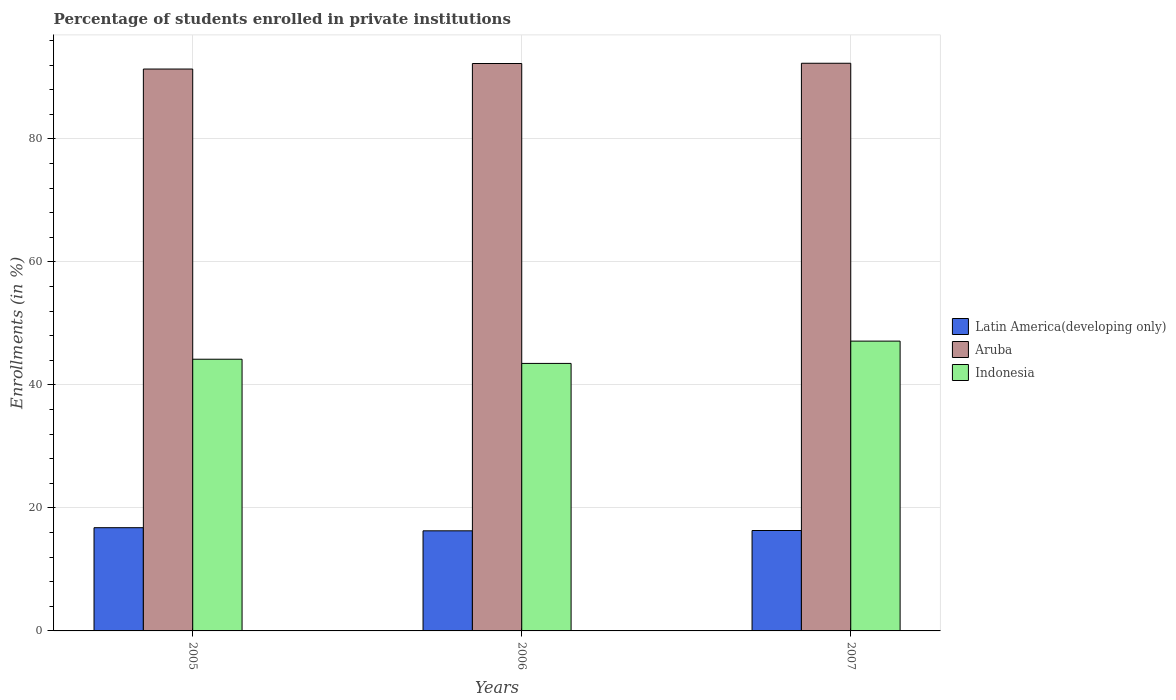How many different coloured bars are there?
Give a very brief answer. 3. What is the label of the 2nd group of bars from the left?
Ensure brevity in your answer.  2006. What is the percentage of trained teachers in Aruba in 2005?
Offer a very short reply. 91.34. Across all years, what is the maximum percentage of trained teachers in Indonesia?
Provide a short and direct response. 47.11. Across all years, what is the minimum percentage of trained teachers in Latin America(developing only)?
Provide a short and direct response. 16.27. In which year was the percentage of trained teachers in Indonesia minimum?
Your answer should be very brief. 2006. What is the total percentage of trained teachers in Indonesia in the graph?
Provide a succinct answer. 134.77. What is the difference between the percentage of trained teachers in Aruba in 2006 and that in 2007?
Ensure brevity in your answer.  -0.04. What is the difference between the percentage of trained teachers in Latin America(developing only) in 2007 and the percentage of trained teachers in Aruba in 2006?
Your answer should be very brief. -75.92. What is the average percentage of trained teachers in Latin America(developing only) per year?
Your response must be concise. 16.46. In the year 2005, what is the difference between the percentage of trained teachers in Indonesia and percentage of trained teachers in Aruba?
Offer a very short reply. -47.17. In how many years, is the percentage of trained teachers in Latin America(developing only) greater than 20 %?
Ensure brevity in your answer.  0. What is the ratio of the percentage of trained teachers in Indonesia in 2006 to that in 2007?
Ensure brevity in your answer.  0.92. What is the difference between the highest and the second highest percentage of trained teachers in Aruba?
Offer a very short reply. 0.04. What is the difference between the highest and the lowest percentage of trained teachers in Indonesia?
Make the answer very short. 3.62. What does the 2nd bar from the left in 2006 represents?
Offer a terse response. Aruba. What does the 3rd bar from the right in 2005 represents?
Make the answer very short. Latin America(developing only). Is it the case that in every year, the sum of the percentage of trained teachers in Indonesia and percentage of trained teachers in Aruba is greater than the percentage of trained teachers in Latin America(developing only)?
Make the answer very short. Yes. How many bars are there?
Offer a very short reply. 9. Are all the bars in the graph horizontal?
Make the answer very short. No. How many years are there in the graph?
Offer a terse response. 3. What is the difference between two consecutive major ticks on the Y-axis?
Make the answer very short. 20. Are the values on the major ticks of Y-axis written in scientific E-notation?
Offer a terse response. No. Does the graph contain grids?
Keep it short and to the point. Yes. Where does the legend appear in the graph?
Make the answer very short. Center right. How many legend labels are there?
Keep it short and to the point. 3. How are the legend labels stacked?
Your answer should be compact. Vertical. What is the title of the graph?
Give a very brief answer. Percentage of students enrolled in private institutions. Does "Low income" appear as one of the legend labels in the graph?
Provide a succinct answer. No. What is the label or title of the Y-axis?
Offer a very short reply. Enrollments (in %). What is the Enrollments (in %) in Latin America(developing only) in 2005?
Your response must be concise. 16.78. What is the Enrollments (in %) in Aruba in 2005?
Offer a terse response. 91.34. What is the Enrollments (in %) of Indonesia in 2005?
Ensure brevity in your answer.  44.17. What is the Enrollments (in %) in Latin America(developing only) in 2006?
Your response must be concise. 16.27. What is the Enrollments (in %) in Aruba in 2006?
Make the answer very short. 92.24. What is the Enrollments (in %) in Indonesia in 2006?
Your answer should be very brief. 43.49. What is the Enrollments (in %) of Latin America(developing only) in 2007?
Provide a short and direct response. 16.32. What is the Enrollments (in %) of Aruba in 2007?
Give a very brief answer. 92.28. What is the Enrollments (in %) of Indonesia in 2007?
Provide a succinct answer. 47.11. Across all years, what is the maximum Enrollments (in %) in Latin America(developing only)?
Ensure brevity in your answer.  16.78. Across all years, what is the maximum Enrollments (in %) in Aruba?
Make the answer very short. 92.28. Across all years, what is the maximum Enrollments (in %) in Indonesia?
Give a very brief answer. 47.11. Across all years, what is the minimum Enrollments (in %) in Latin America(developing only)?
Make the answer very short. 16.27. Across all years, what is the minimum Enrollments (in %) in Aruba?
Provide a short and direct response. 91.34. Across all years, what is the minimum Enrollments (in %) of Indonesia?
Give a very brief answer. 43.49. What is the total Enrollments (in %) in Latin America(developing only) in the graph?
Offer a terse response. 49.38. What is the total Enrollments (in %) in Aruba in the graph?
Your response must be concise. 275.87. What is the total Enrollments (in %) in Indonesia in the graph?
Offer a very short reply. 134.77. What is the difference between the Enrollments (in %) of Latin America(developing only) in 2005 and that in 2006?
Your response must be concise. 0.51. What is the difference between the Enrollments (in %) of Aruba in 2005 and that in 2006?
Offer a terse response. -0.9. What is the difference between the Enrollments (in %) of Indonesia in 2005 and that in 2006?
Provide a short and direct response. 0.68. What is the difference between the Enrollments (in %) of Latin America(developing only) in 2005 and that in 2007?
Keep it short and to the point. 0.46. What is the difference between the Enrollments (in %) of Aruba in 2005 and that in 2007?
Provide a succinct answer. -0.94. What is the difference between the Enrollments (in %) of Indonesia in 2005 and that in 2007?
Ensure brevity in your answer.  -2.94. What is the difference between the Enrollments (in %) of Latin America(developing only) in 2006 and that in 2007?
Your answer should be very brief. -0.05. What is the difference between the Enrollments (in %) in Aruba in 2006 and that in 2007?
Give a very brief answer. -0.04. What is the difference between the Enrollments (in %) in Indonesia in 2006 and that in 2007?
Your answer should be compact. -3.62. What is the difference between the Enrollments (in %) of Latin America(developing only) in 2005 and the Enrollments (in %) of Aruba in 2006?
Provide a short and direct response. -75.46. What is the difference between the Enrollments (in %) of Latin America(developing only) in 2005 and the Enrollments (in %) of Indonesia in 2006?
Offer a very short reply. -26.71. What is the difference between the Enrollments (in %) in Aruba in 2005 and the Enrollments (in %) in Indonesia in 2006?
Your response must be concise. 47.85. What is the difference between the Enrollments (in %) in Latin America(developing only) in 2005 and the Enrollments (in %) in Aruba in 2007?
Your answer should be compact. -75.5. What is the difference between the Enrollments (in %) in Latin America(developing only) in 2005 and the Enrollments (in %) in Indonesia in 2007?
Offer a terse response. -30.33. What is the difference between the Enrollments (in %) of Aruba in 2005 and the Enrollments (in %) of Indonesia in 2007?
Keep it short and to the point. 44.23. What is the difference between the Enrollments (in %) of Latin America(developing only) in 2006 and the Enrollments (in %) of Aruba in 2007?
Provide a succinct answer. -76.01. What is the difference between the Enrollments (in %) in Latin America(developing only) in 2006 and the Enrollments (in %) in Indonesia in 2007?
Your answer should be compact. -30.84. What is the difference between the Enrollments (in %) in Aruba in 2006 and the Enrollments (in %) in Indonesia in 2007?
Offer a terse response. 45.13. What is the average Enrollments (in %) in Latin America(developing only) per year?
Your answer should be very brief. 16.46. What is the average Enrollments (in %) in Aruba per year?
Your response must be concise. 91.96. What is the average Enrollments (in %) of Indonesia per year?
Your response must be concise. 44.92. In the year 2005, what is the difference between the Enrollments (in %) in Latin America(developing only) and Enrollments (in %) in Aruba?
Ensure brevity in your answer.  -74.56. In the year 2005, what is the difference between the Enrollments (in %) in Latin America(developing only) and Enrollments (in %) in Indonesia?
Keep it short and to the point. -27.39. In the year 2005, what is the difference between the Enrollments (in %) in Aruba and Enrollments (in %) in Indonesia?
Your answer should be very brief. 47.17. In the year 2006, what is the difference between the Enrollments (in %) in Latin America(developing only) and Enrollments (in %) in Aruba?
Make the answer very short. -75.97. In the year 2006, what is the difference between the Enrollments (in %) of Latin America(developing only) and Enrollments (in %) of Indonesia?
Offer a terse response. -27.22. In the year 2006, what is the difference between the Enrollments (in %) of Aruba and Enrollments (in %) of Indonesia?
Ensure brevity in your answer.  48.76. In the year 2007, what is the difference between the Enrollments (in %) in Latin America(developing only) and Enrollments (in %) in Aruba?
Your response must be concise. -75.96. In the year 2007, what is the difference between the Enrollments (in %) of Latin America(developing only) and Enrollments (in %) of Indonesia?
Offer a very short reply. -30.79. In the year 2007, what is the difference between the Enrollments (in %) of Aruba and Enrollments (in %) of Indonesia?
Provide a short and direct response. 45.17. What is the ratio of the Enrollments (in %) of Latin America(developing only) in 2005 to that in 2006?
Offer a terse response. 1.03. What is the ratio of the Enrollments (in %) of Aruba in 2005 to that in 2006?
Ensure brevity in your answer.  0.99. What is the ratio of the Enrollments (in %) of Indonesia in 2005 to that in 2006?
Your answer should be very brief. 1.02. What is the ratio of the Enrollments (in %) of Latin America(developing only) in 2005 to that in 2007?
Keep it short and to the point. 1.03. What is the difference between the highest and the second highest Enrollments (in %) of Latin America(developing only)?
Make the answer very short. 0.46. What is the difference between the highest and the second highest Enrollments (in %) of Aruba?
Give a very brief answer. 0.04. What is the difference between the highest and the second highest Enrollments (in %) of Indonesia?
Your answer should be compact. 2.94. What is the difference between the highest and the lowest Enrollments (in %) of Latin America(developing only)?
Provide a succinct answer. 0.51. What is the difference between the highest and the lowest Enrollments (in %) of Aruba?
Your answer should be very brief. 0.94. What is the difference between the highest and the lowest Enrollments (in %) of Indonesia?
Offer a terse response. 3.62. 